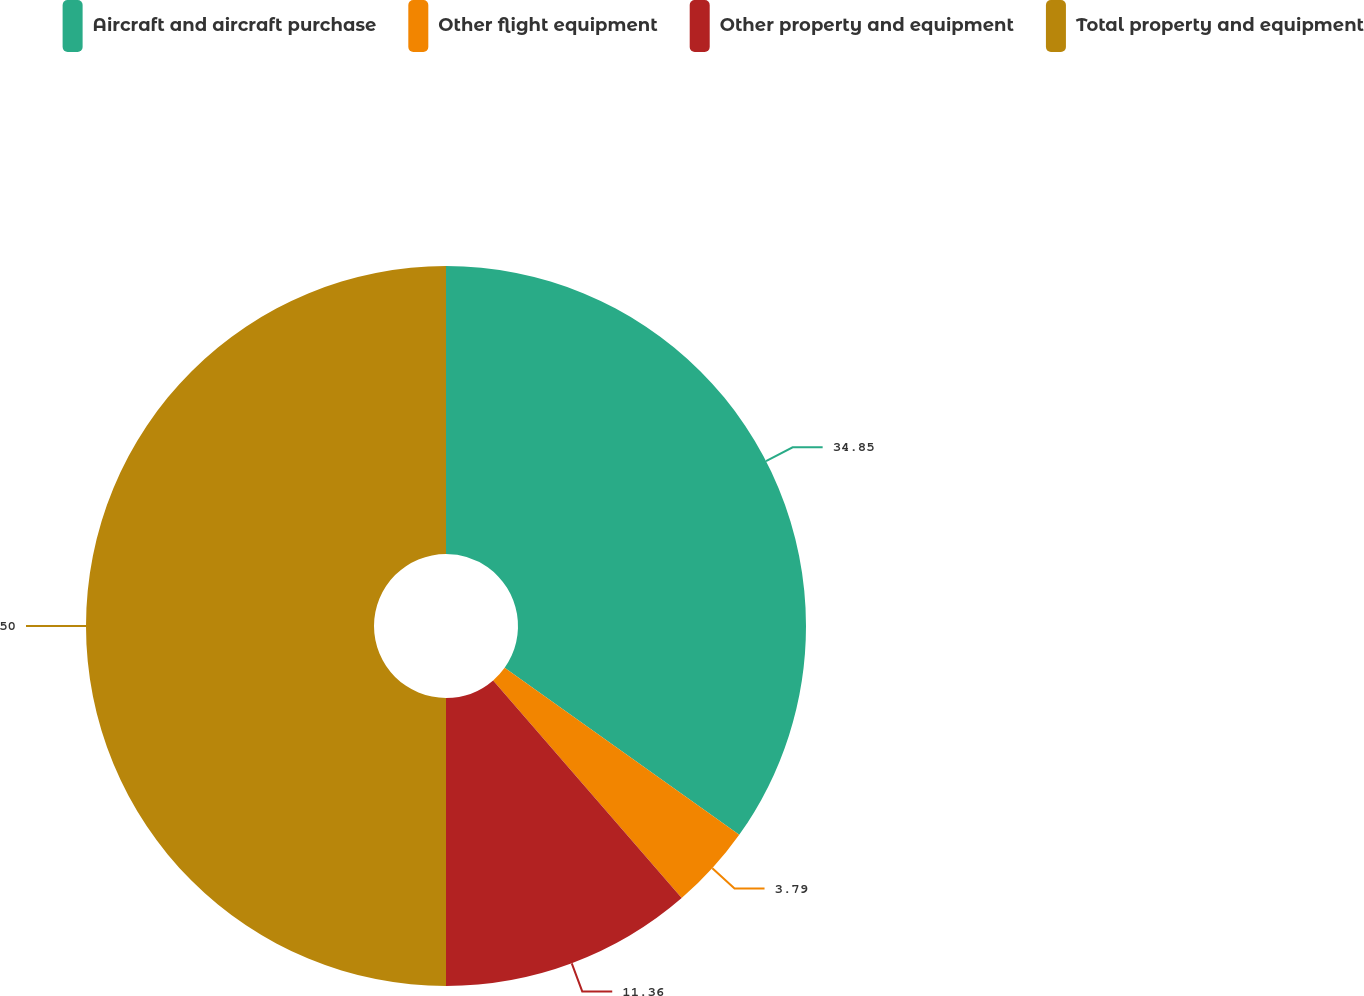<chart> <loc_0><loc_0><loc_500><loc_500><pie_chart><fcel>Aircraft and aircraft purchase<fcel>Other flight equipment<fcel>Other property and equipment<fcel>Total property and equipment<nl><fcel>34.85%<fcel>3.79%<fcel>11.36%<fcel>50.0%<nl></chart> 